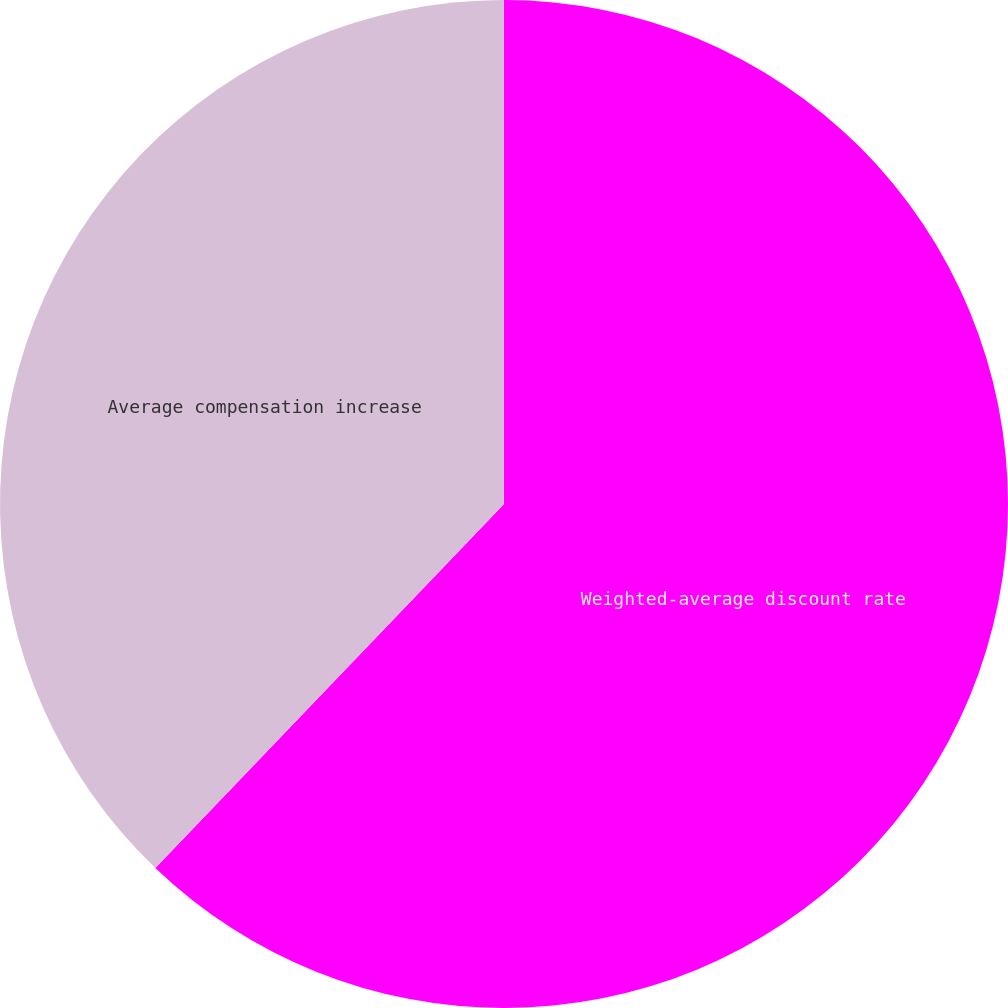<chart> <loc_0><loc_0><loc_500><loc_500><pie_chart><fcel>Weighted-average discount rate<fcel>Average compensation increase<nl><fcel>62.16%<fcel>37.84%<nl></chart> 